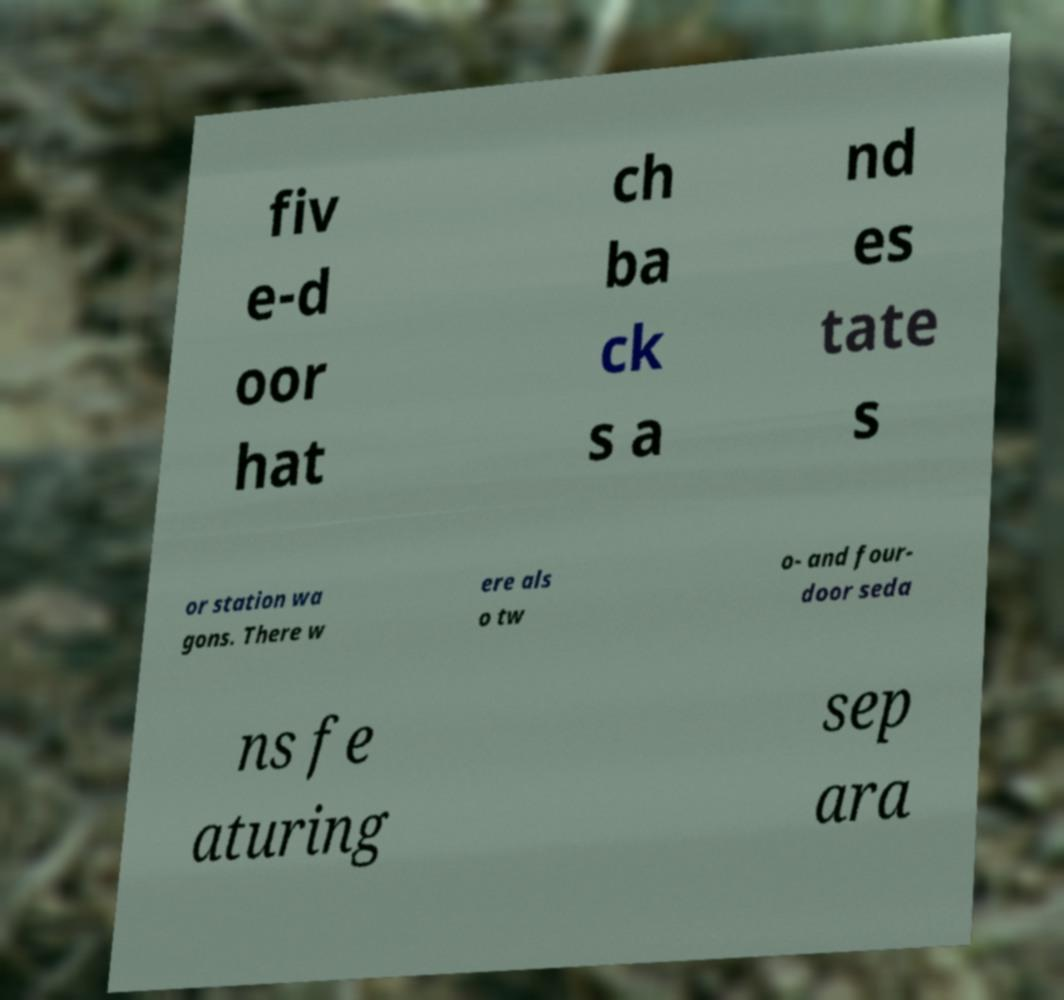Can you read and provide the text displayed in the image?This photo seems to have some interesting text. Can you extract and type it out for me? fiv e-d oor hat ch ba ck s a nd es tate s or station wa gons. There w ere als o tw o- and four- door seda ns fe aturing sep ara 